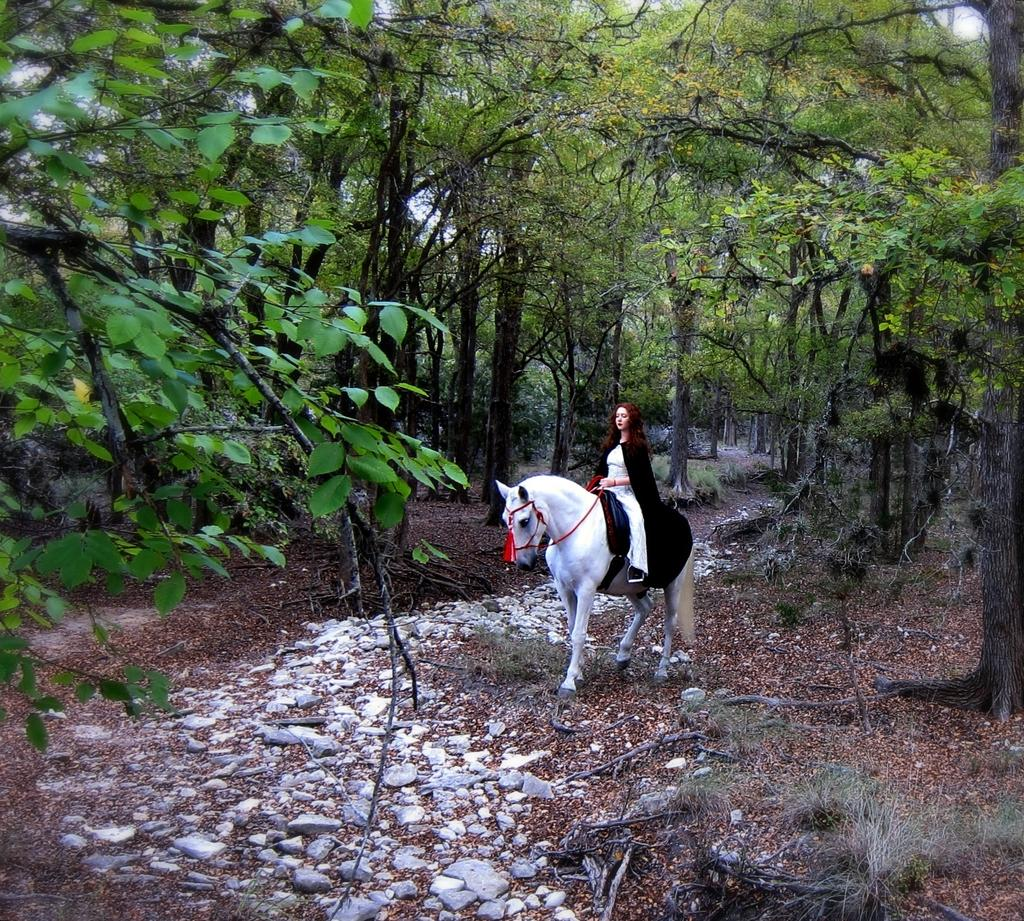Who is the main subject in the image? There is a woman in the image. What is the woman doing in the image? The woman is on a horse. What is the position of the horse in the image? The horse is on the ground. What can be seen in the background of the image? There are trees in the background of the image. What type of surface is visible in the image? Stones are visible in the image. What type of liquid is being poured by the woman in the image? There is no liquid being poured in the image; the woman is on a horse. 